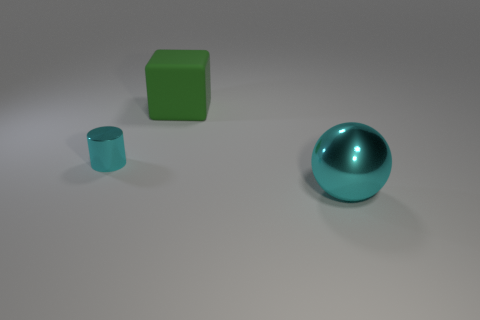Add 1 large red metallic cylinders. How many objects exist? 4 Subtract all cubes. How many objects are left? 2 Subtract all big matte objects. Subtract all big balls. How many objects are left? 1 Add 3 large green rubber blocks. How many large green rubber blocks are left? 4 Add 3 matte objects. How many matte objects exist? 4 Subtract 1 cyan spheres. How many objects are left? 2 